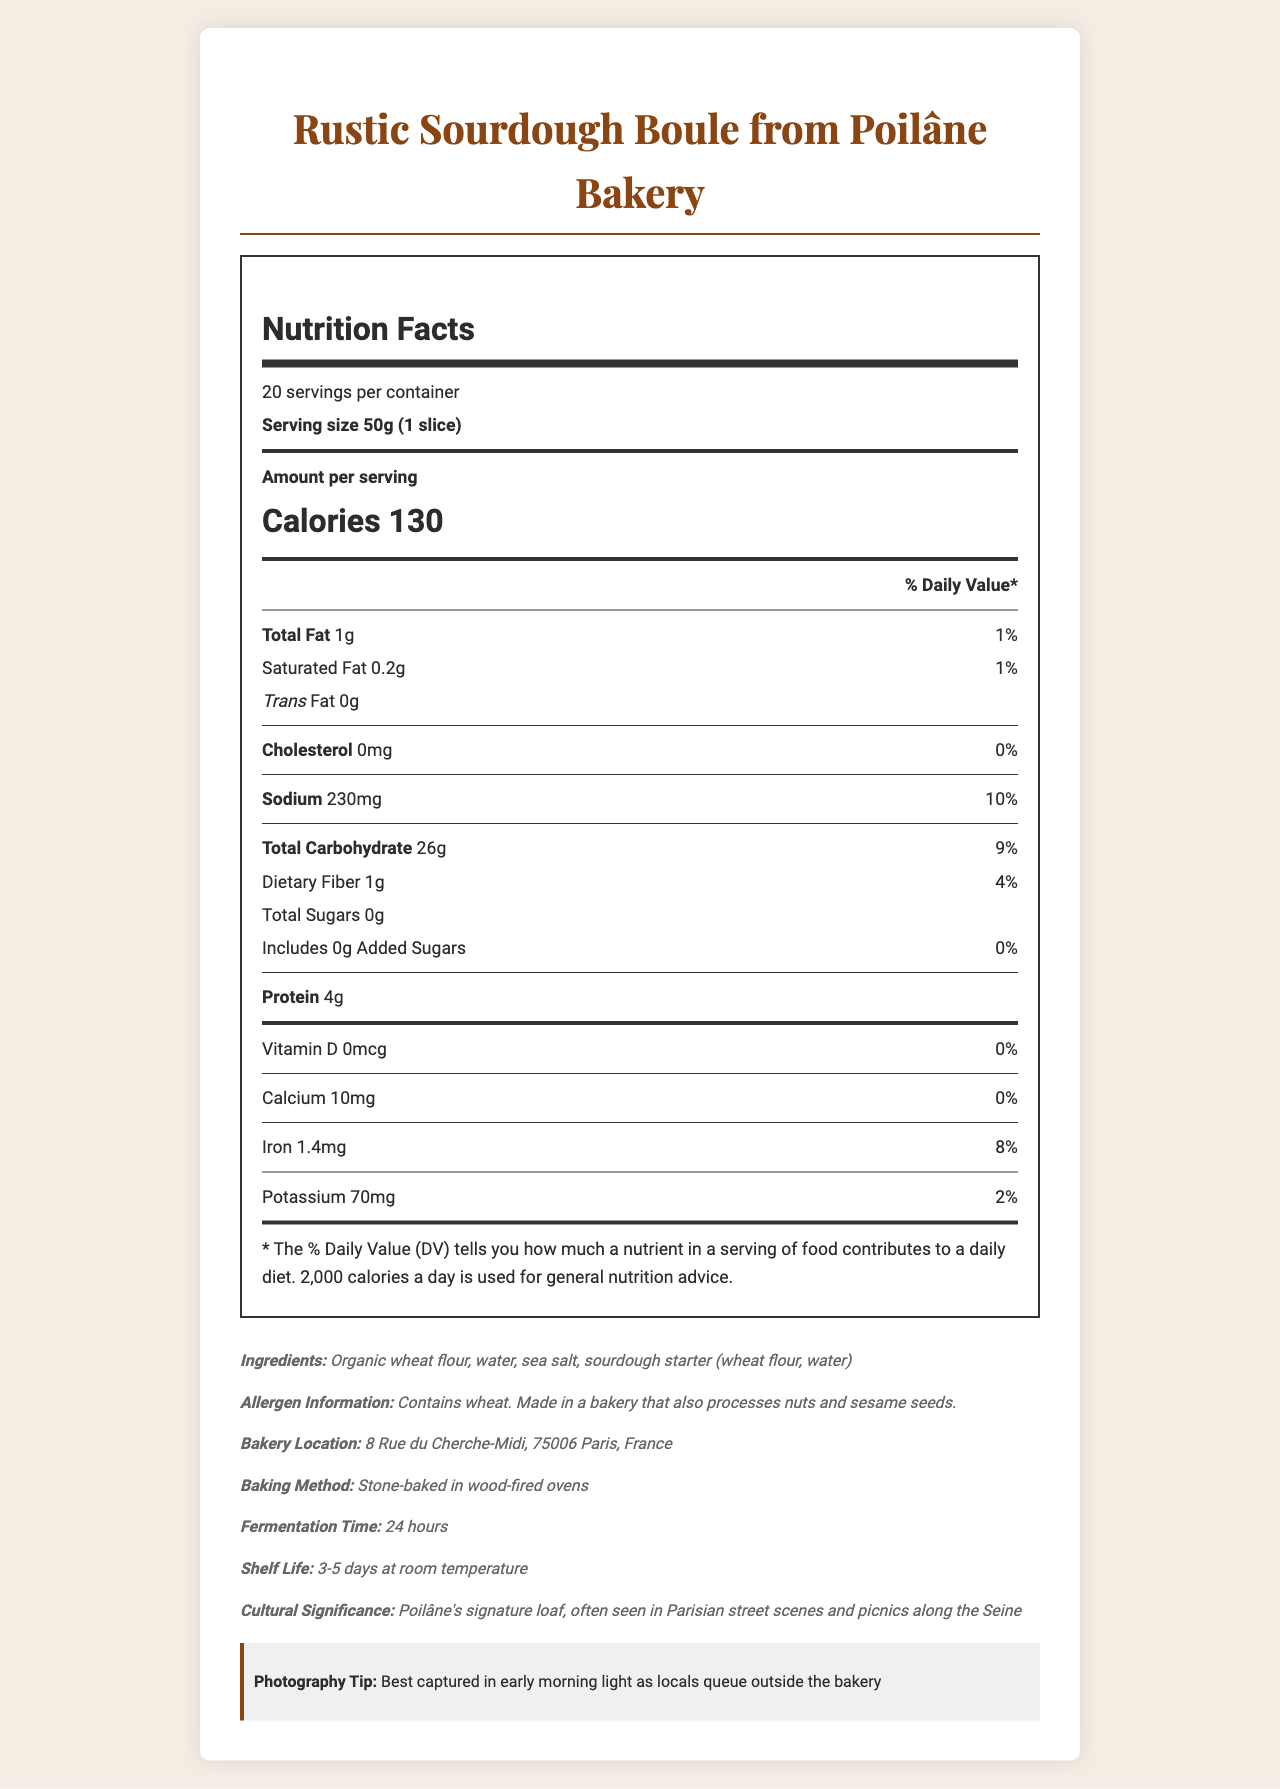what is the serving size for the Rustic Sourdough Boule? The serving size is clearly stated as 50g (1 slice) on the label.
Answer: 50g (1 slice) How many servings are there per container? The label specifies that there are 20 servings per container.
Answer: 20 What is the total calorie content per serving? The document lists the calorie content per serving as 130.
Answer: 130 calories How much sodium is in one serving of the Rustic Sourdough Boule? The sodium content per serving is provided as 230mg.
Answer: 230mg What is the fermentation time for the Rustic Sourdough Boule? The additional information section mentions the fermentation time as 24 hours.
Answer: 24 hours Does one serving of the bread contain any trans fat? The label indicates that the bread contains 0g of trans fat per serving.
Answer: No Does the bread contain any added sugars? According to the label, the bread contains 0g of added sugars.
Answer: No Where is Poilâne Bakery located? The location of the bakery is listed as 8 Rue du Cherche-Midi, 75006 Paris, France.
Answer: 8 Rue du Cherche-Midi, 75006 Paris, France What type of ovens are used to bake the bread? The baking method specified is stone-baked in wood-fired ovens.
Answer: Stone-baked in wood-fired ovens Which of the following contains the lowest percentage of Daily Value? A. Sodium B. Calcium C. Iron D. Protein The Daily Value for calcium is 0%, which is the lowest among the options given.
Answer: B. Calcium What is the approximate shelf life of the bread? A. 1-2 days B. 3-5 days C. 6-7 days D. 8-10 days The label mentions that the shelf life at room temperature is 3-5 days.
Answer: B. 3-5 days Which nutrient has the highest percentage of Daily Value per serving? A. Total Fat B. Protein C. Iron D. Sodium Sodium has the highest daily value percentage at 10%.
Answer: D. Sodium Does this bread contain any allergens? The allergen information states that it contains wheat and is made in a bakery that processes nuts and sesame seeds.
Answer: Yes Summarize the main idea of the document. The document gives a comprehensive overview of the nutritional content of the bread, its ingredients, location, and significance, including some tips for capturing it in photographs.
Answer: The document provides detailed nutritional information and additional details about the Rustic Sourdough Boule from Poilâne Bakery in Paris. It also includes ingredients, allergen information, and some cultural and photography tips. How many grams of dietary fiber does one serving contain? Each serving contains 1g of dietary fiber, according to the nutritional label.
Answer: 1g What is the main ingredient in the bread? The primary ingredient listed is organic wheat flour.
Answer: Organic wheat flour Is this bread high in cholesterol? The label indicates that the bread contains 0mg of cholesterol.
Answer: No How many grams of protein are in one serving? The nutritional label shows that there are 4g of protein per serving.
Answer: 4g What is the cultural significance of the Rustic Sourdough Boule? The document describes its cultural importance, highlighting the bread as Poilâne's signature loaf often found in Parisian street scenes and picnics along the Seine.
Answer: "Poilâne's signature loaf, often seen in Parisian street scenes and picnics along the Seine" What vitamin is absent from the Rustic Sourdough Boule? The label states that Vitamin D is 0mcg, indicating its absence.
Answer: Vitamin D What are the exact coordinates of the Poilâne Bakery? The document provides the street address but does not include geographical coordinates.
Answer: Cannot be determined How much calcium does one serving of the bread provide? The label shows that one serving contains 10mg of calcium.
Answer: 10mg What type of light is suggested for photographing the bread? The photography tip suggests capturing the bread in early morning light.
Answer: Early morning light 